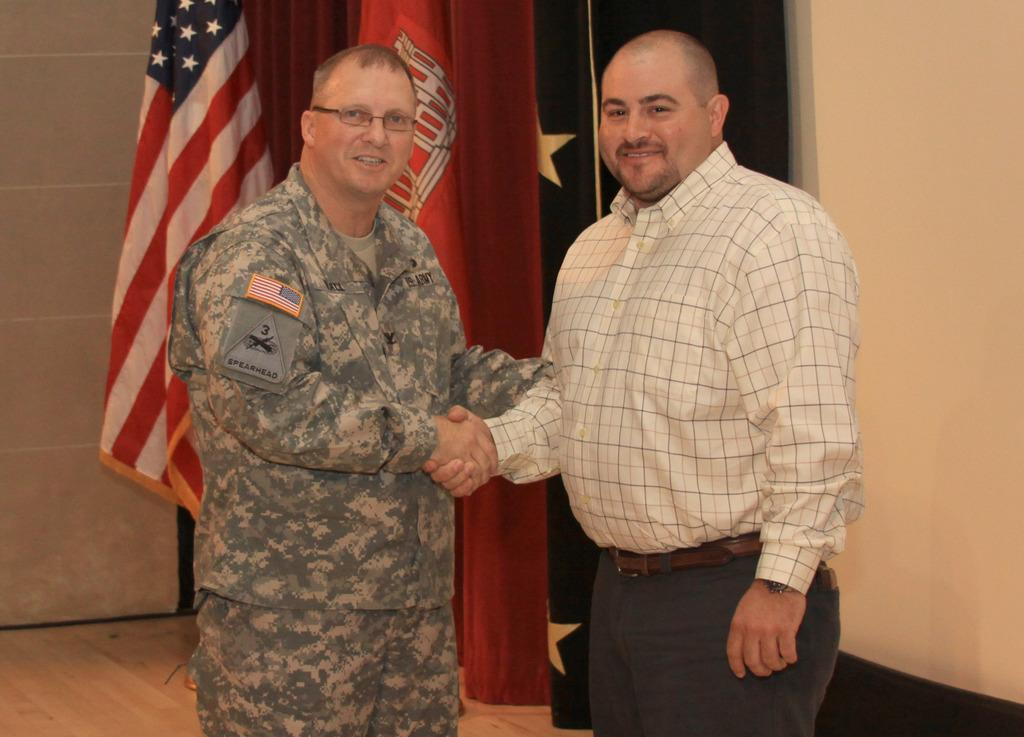How many people are present in the image? There are two men standing in the image. What is the surface on which the men are standing? The men are standing on the floor. What can be seen in the background of the image? There are flags visible in the image. What type of covering is present in the image? There is a curtain in the image. What is the main architectural feature in the image? There is a wall in the image. Can you see any fairies flying around the men in the image? No, there are no fairies visible in the image. Is there a bike present in the image? No, there is no bike present in the image. 